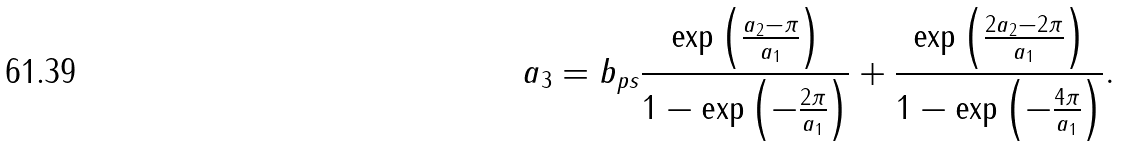<formula> <loc_0><loc_0><loc_500><loc_500>a _ { 3 } = b _ { p s } \frac { \exp \left ( \frac { a _ { 2 } - \pi } { a _ { 1 } } \right ) } { 1 - \exp \left ( - \frac { 2 \pi } { a _ { 1 } } \right ) } + \frac { \exp \left ( \frac { 2 a _ { 2 } - 2 \pi } { a _ { 1 } } \right ) } { 1 - \exp \left ( - \frac { 4 \pi } { a _ { 1 } } \right ) } .</formula> 